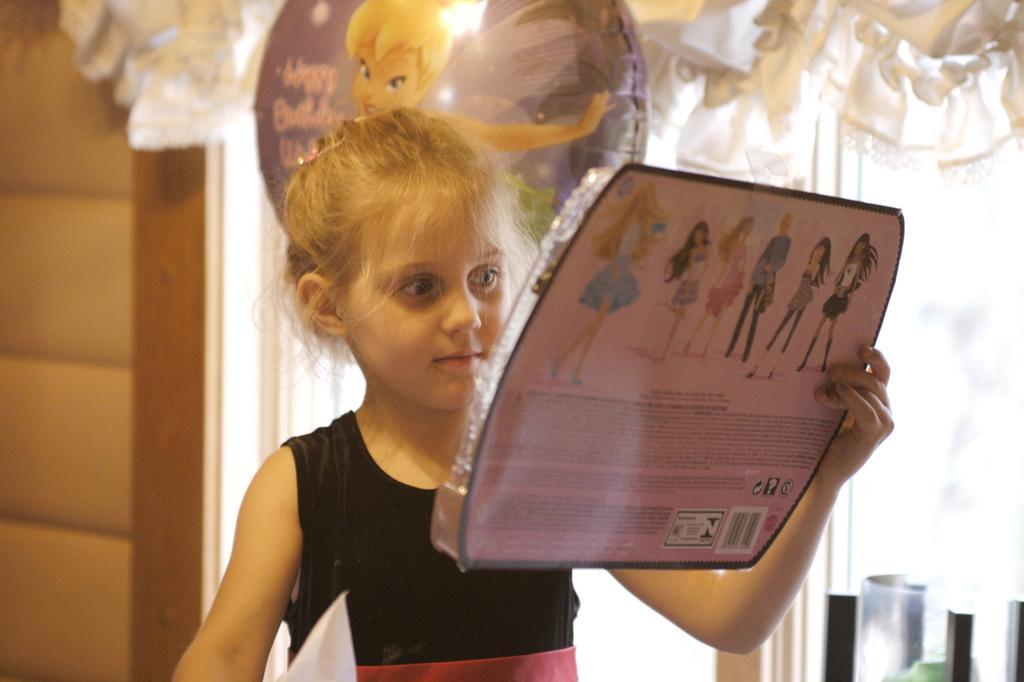How would you summarize this image in a sentence or two? In this image, we can see a girl holding an object. We can see some wood and some glass. We can also see some ribbons and a ball. We can also see some objects on the bottom right corner. 